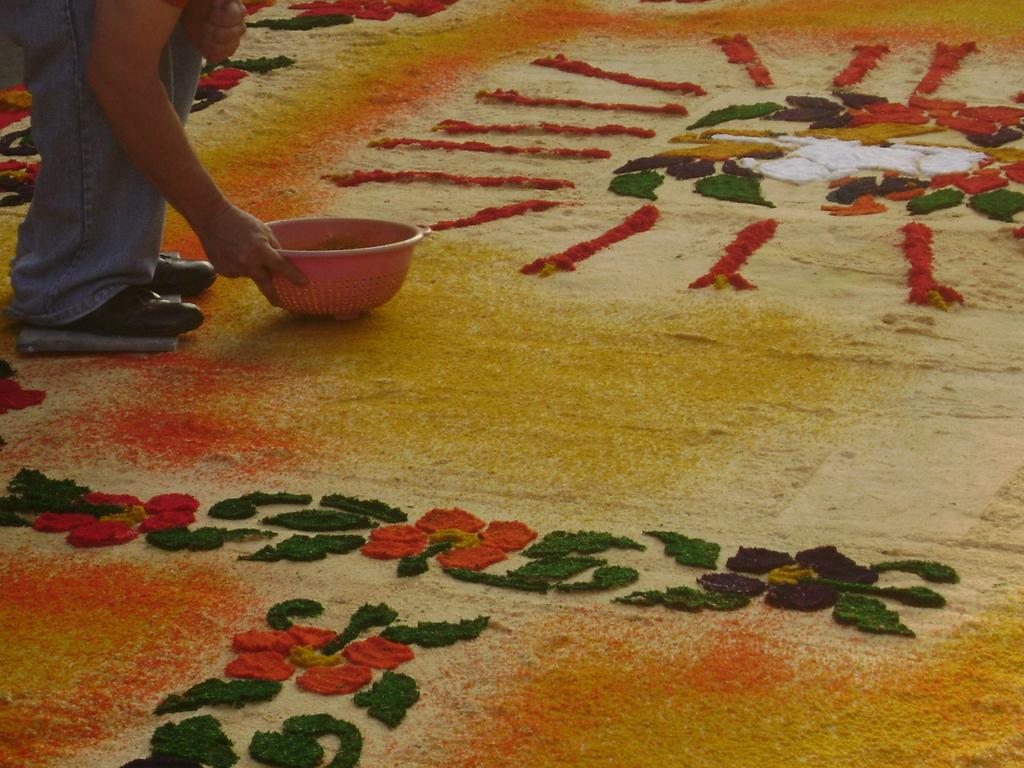What is the main subject of the image? There is a person in the image. What is the person doing in the image? The person is bending and creating designs on the floor with colors. What is the person holding in the image? The person is holding a bowl on the floor. What type of trees can be seen in the background of the image? There are no trees visible in the image; it features a person creating designs on the floor with colors. Is there a beggar present in the image? There is no mention of a beggar in the image, only a person creating designs on the floor with colors. 